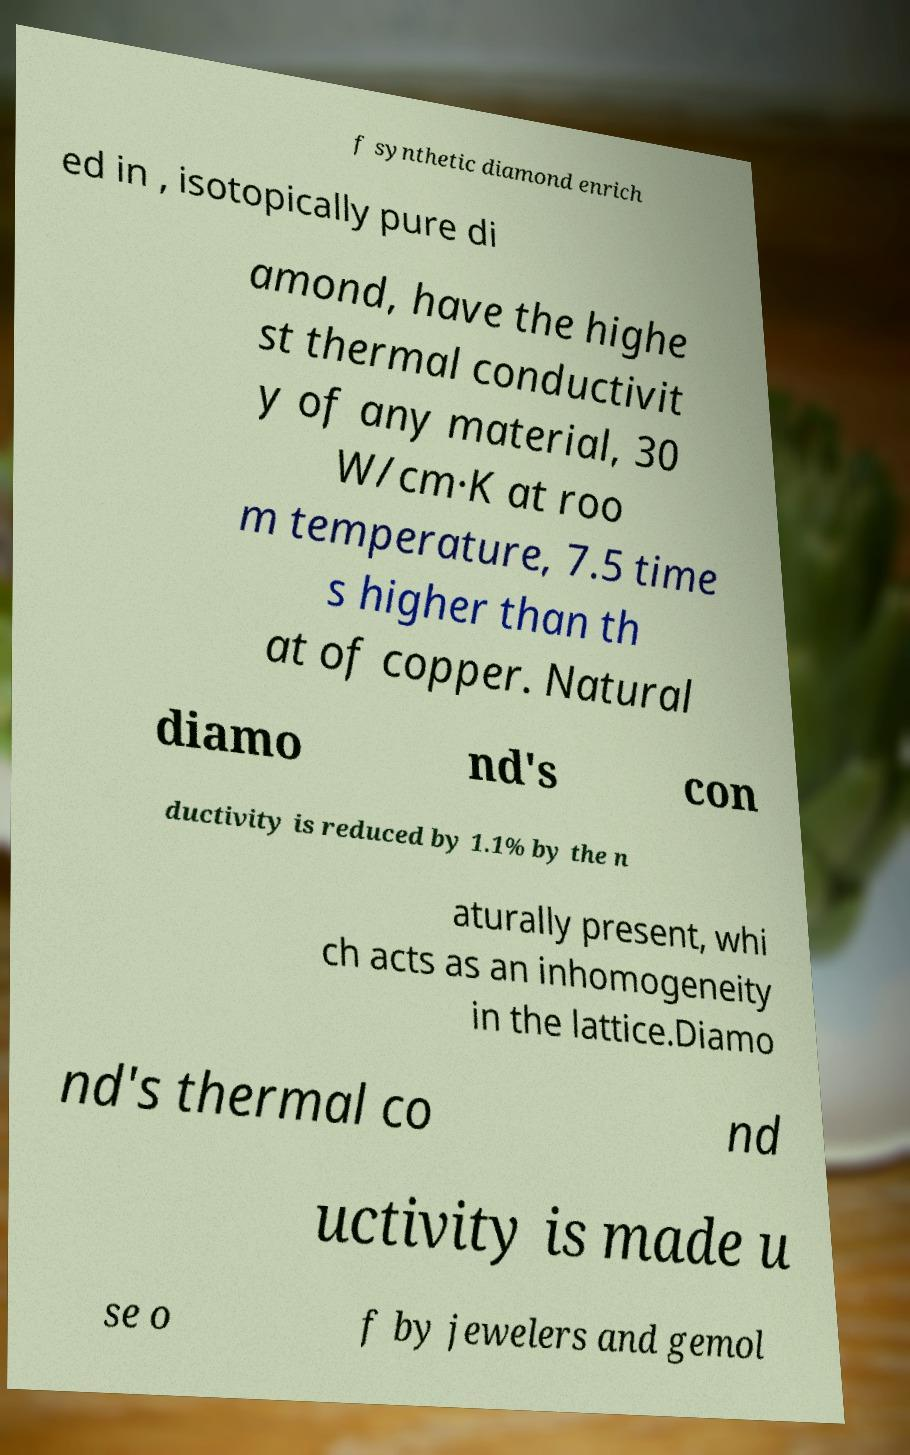There's text embedded in this image that I need extracted. Can you transcribe it verbatim? f synthetic diamond enrich ed in , isotopically pure di amond, have the highe st thermal conductivit y of any material, 30 W/cm·K at roo m temperature, 7.5 time s higher than th at of copper. Natural diamo nd's con ductivity is reduced by 1.1% by the n aturally present, whi ch acts as an inhomogeneity in the lattice.Diamo nd's thermal co nd uctivity is made u se o f by jewelers and gemol 